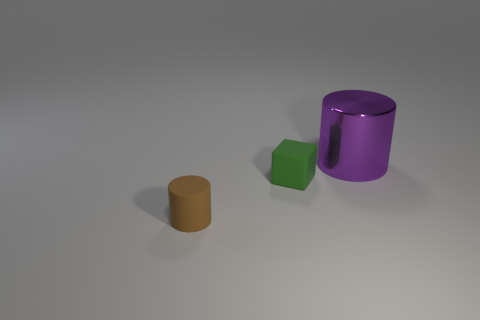Add 3 small purple rubber spheres. How many objects exist? 6 Subtract all cubes. How many objects are left? 2 Subtract all large cylinders. Subtract all cylinders. How many objects are left? 0 Add 3 purple shiny cylinders. How many purple shiny cylinders are left? 4 Add 3 large cylinders. How many large cylinders exist? 4 Subtract 0 blue cubes. How many objects are left? 3 